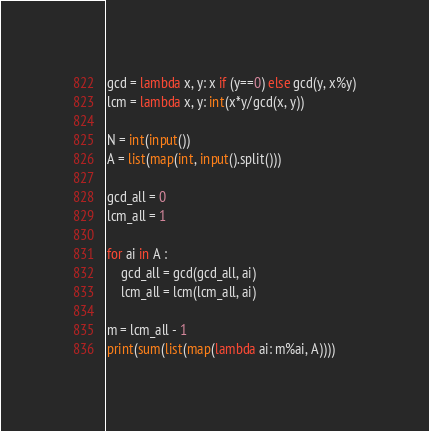<code> <loc_0><loc_0><loc_500><loc_500><_Python_>gcd = lambda x, y: x if (y==0) else gcd(y, x%y)
lcm = lambda x, y: int(x*y/gcd(x, y))

N = int(input())
A = list(map(int, input().split()))

gcd_all = 0
lcm_all = 1

for ai in A :
    gcd_all = gcd(gcd_all, ai)
    lcm_all = lcm(lcm_all, ai)

m = lcm_all - 1
print(sum(list(map(lambda ai: m%ai, A))))
</code> 